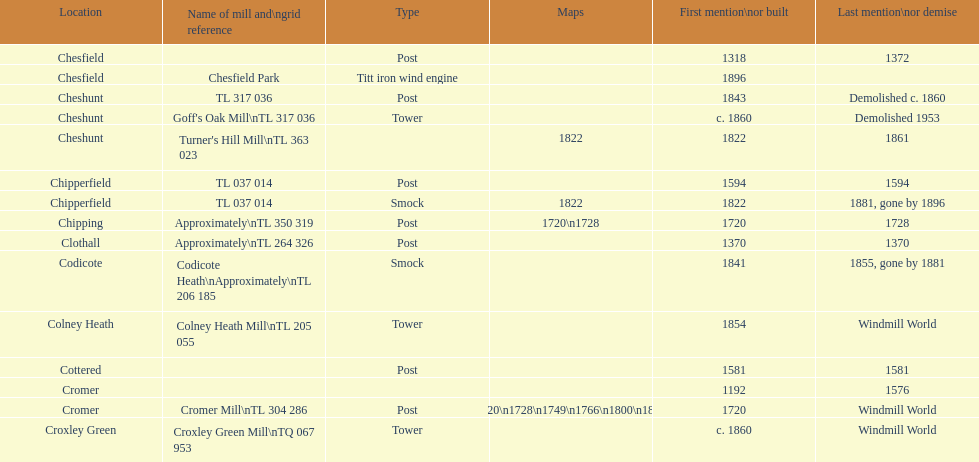How many mills were created or initially cited after 1800? 8. 